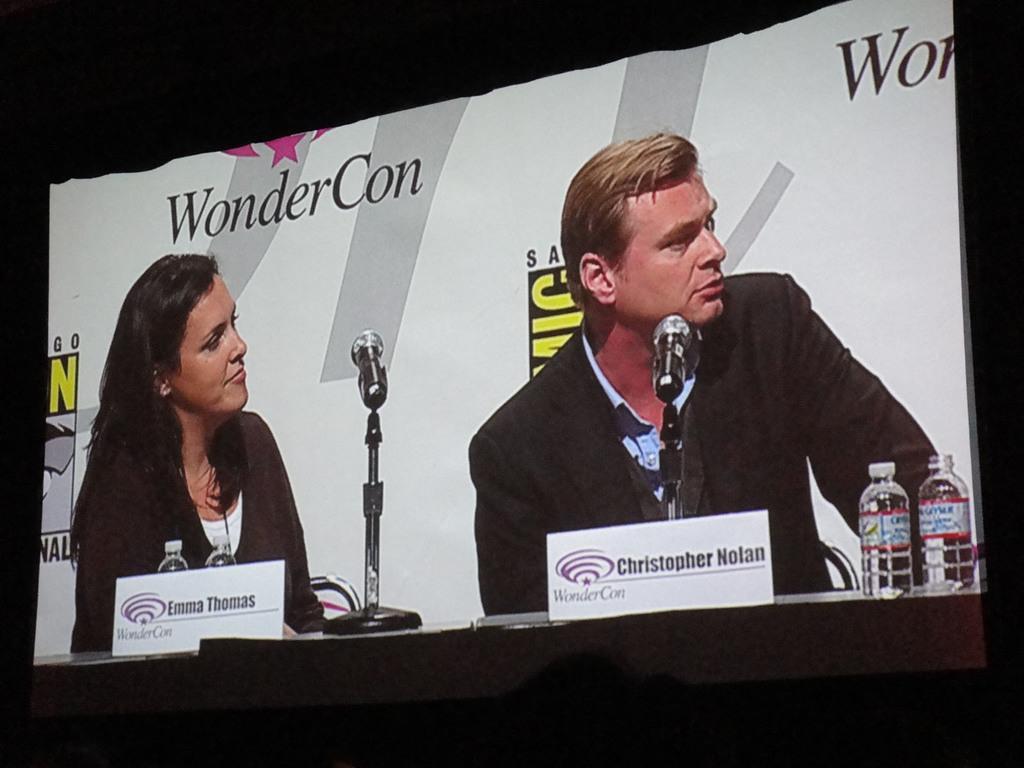Please provide a concise description of this image. In this image there is a screen and on the screen we can a man and a woman sitting in front of mics and also bottles and name boards. 